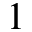Convert formula to latex. <formula><loc_0><loc_0><loc_500><loc_500>1</formula> 